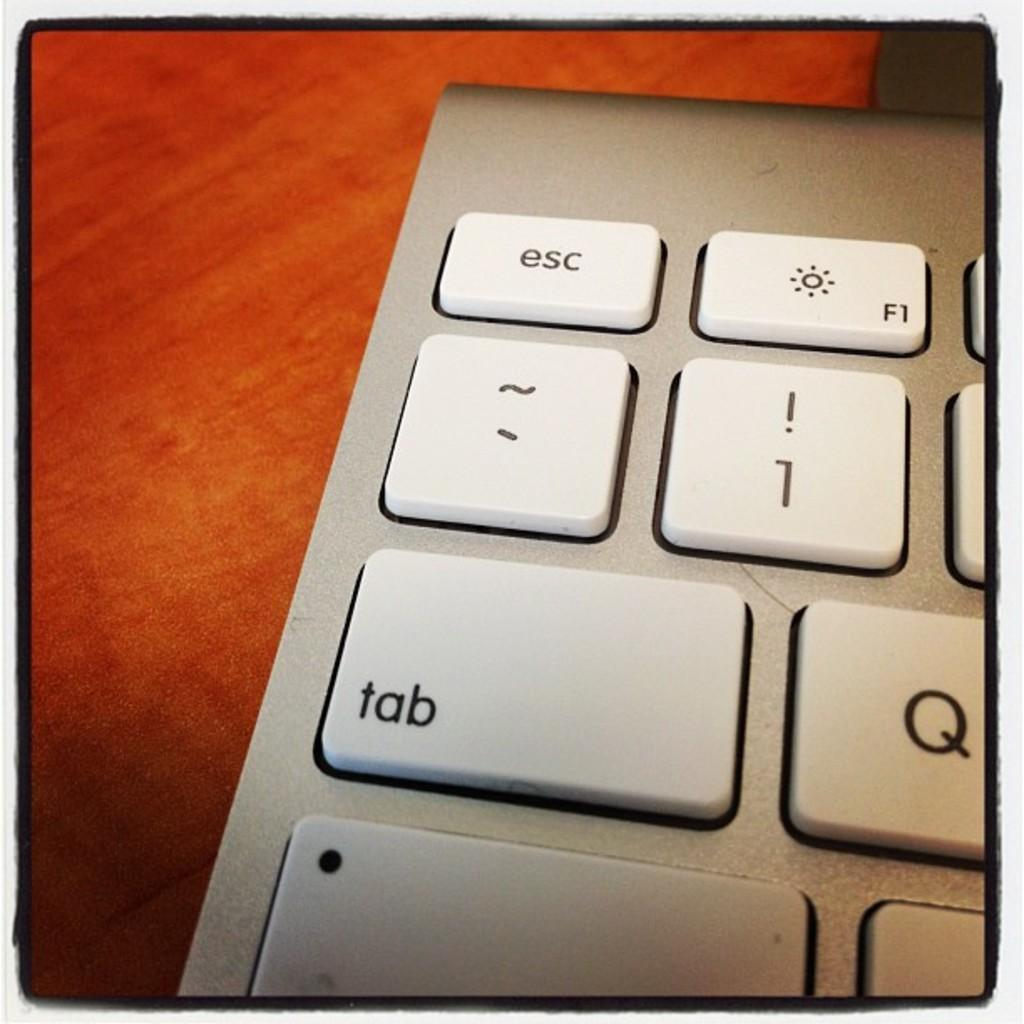<image>
Provide a brief description of the given image. the upper left hand side of a gray and white keyboard, with tab and esc keys plainly visible 